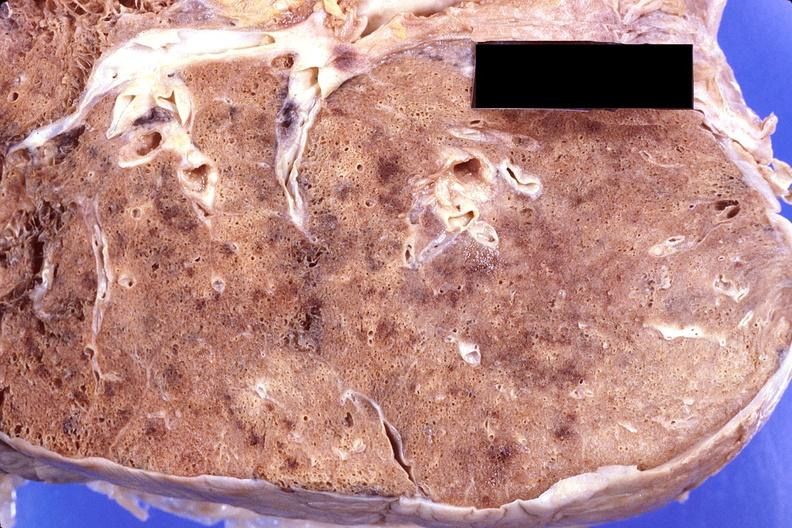does close-up of lesion show lung, cryptococcal pneumonia?
Answer the question using a single word or phrase. No 